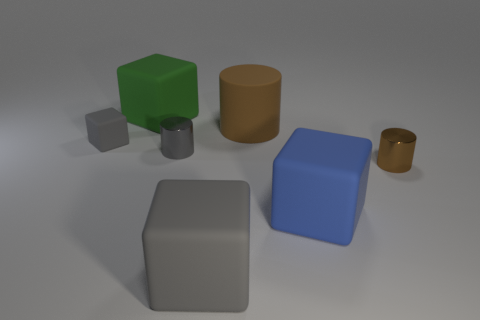The small metal thing that is the same color as the tiny rubber cube is what shape?
Provide a short and direct response. Cylinder. There is a brown cylinder that is in front of the rubber block that is left of the large green block; how big is it?
Make the answer very short. Small. Are there more large brown rubber cylinders than matte things?
Offer a very short reply. No. Is the number of large gray matte blocks on the right side of the blue matte cube greater than the number of small rubber objects in front of the small brown object?
Your answer should be very brief. No. There is a block that is in front of the gray metal cylinder and left of the large brown rubber thing; what is its size?
Your response must be concise. Large. What number of gray shiny things have the same size as the green rubber cube?
Your answer should be very brief. 0. What material is the object that is the same color as the big matte cylinder?
Make the answer very short. Metal. Is the shape of the brown thing in front of the tiny gray rubber thing the same as  the blue matte object?
Give a very brief answer. No. Is the number of large matte cylinders that are behind the tiny brown metal object less than the number of big brown rubber cylinders?
Ensure brevity in your answer.  No. Are there any large cubes that have the same color as the small matte object?
Provide a short and direct response. Yes. 